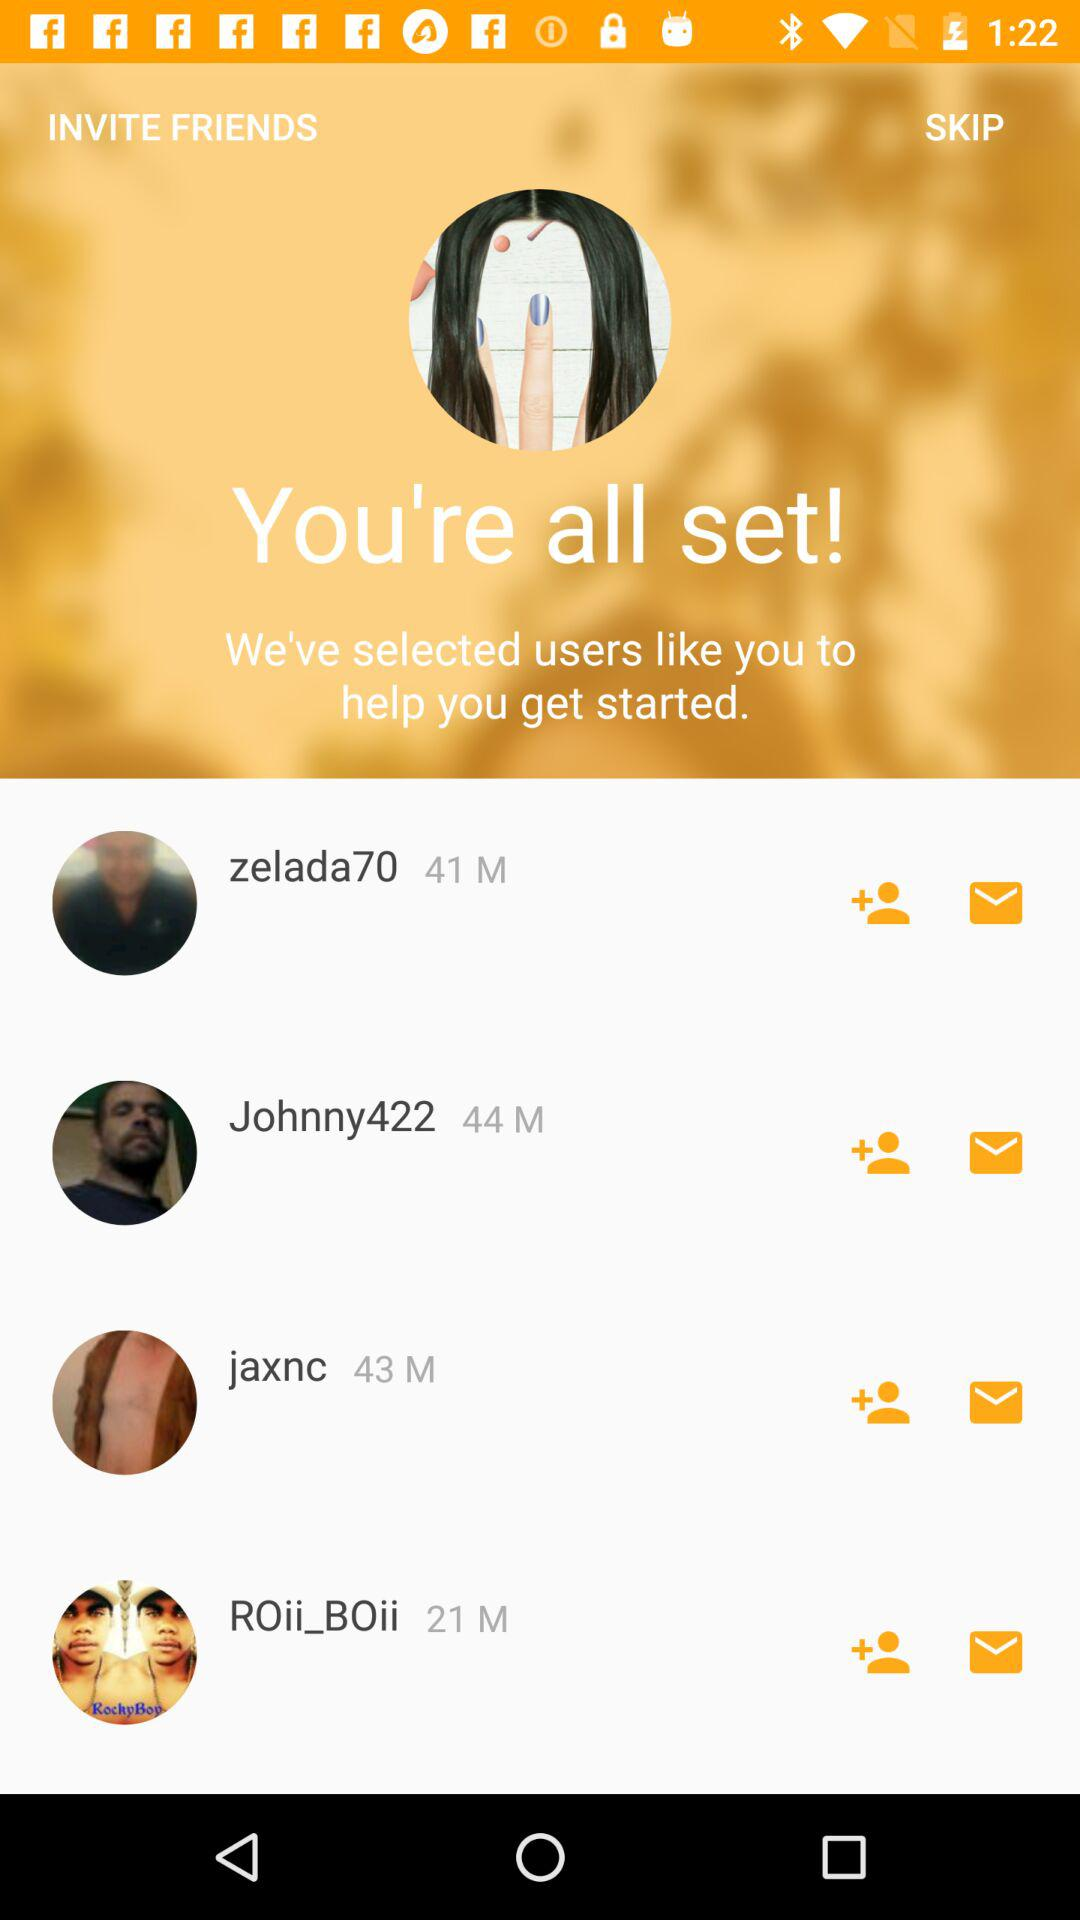What is the gender of Jaxnc?
When the provided information is insufficient, respond with <no answer>. <no answer> 